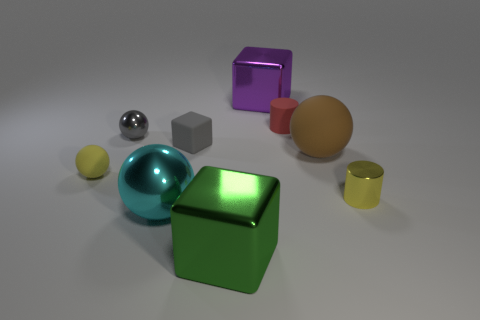Subtract all tiny yellow spheres. How many spheres are left? 3 Subtract 2 spheres. How many spheres are left? 2 Add 8 cyan metallic things. How many cyan metallic things are left? 9 Add 4 red shiny cylinders. How many red shiny cylinders exist? 4 Add 1 large red metallic cylinders. How many objects exist? 10 Subtract all yellow balls. How many balls are left? 3 Subtract 0 gray cylinders. How many objects are left? 9 Subtract all cylinders. How many objects are left? 7 Subtract all gray cylinders. Subtract all cyan balls. How many cylinders are left? 2 Subtract all purple cylinders. How many green blocks are left? 1 